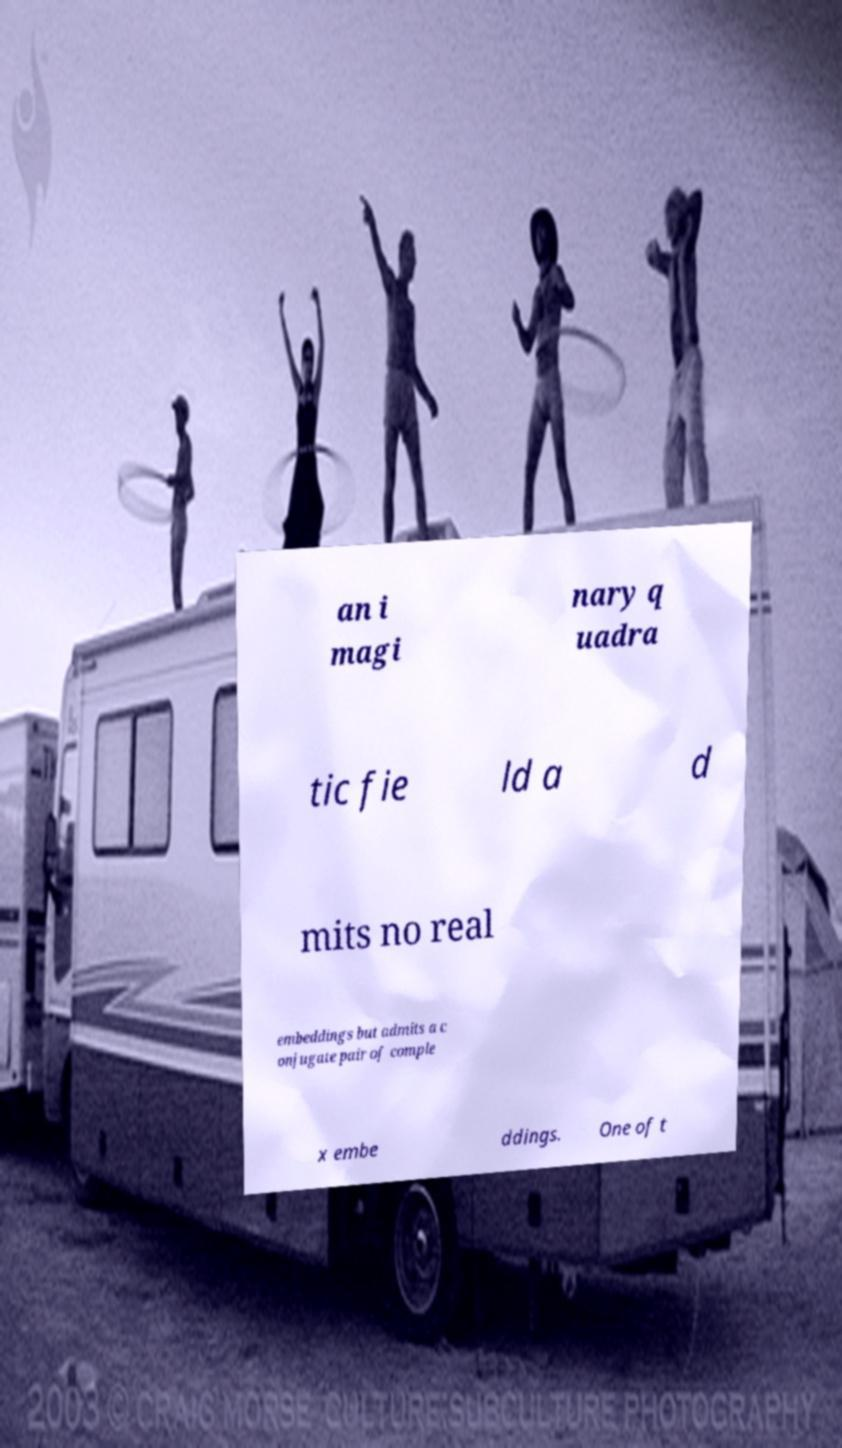For documentation purposes, I need the text within this image transcribed. Could you provide that? an i magi nary q uadra tic fie ld a d mits no real embeddings but admits a c onjugate pair of comple x embe ddings. One of t 